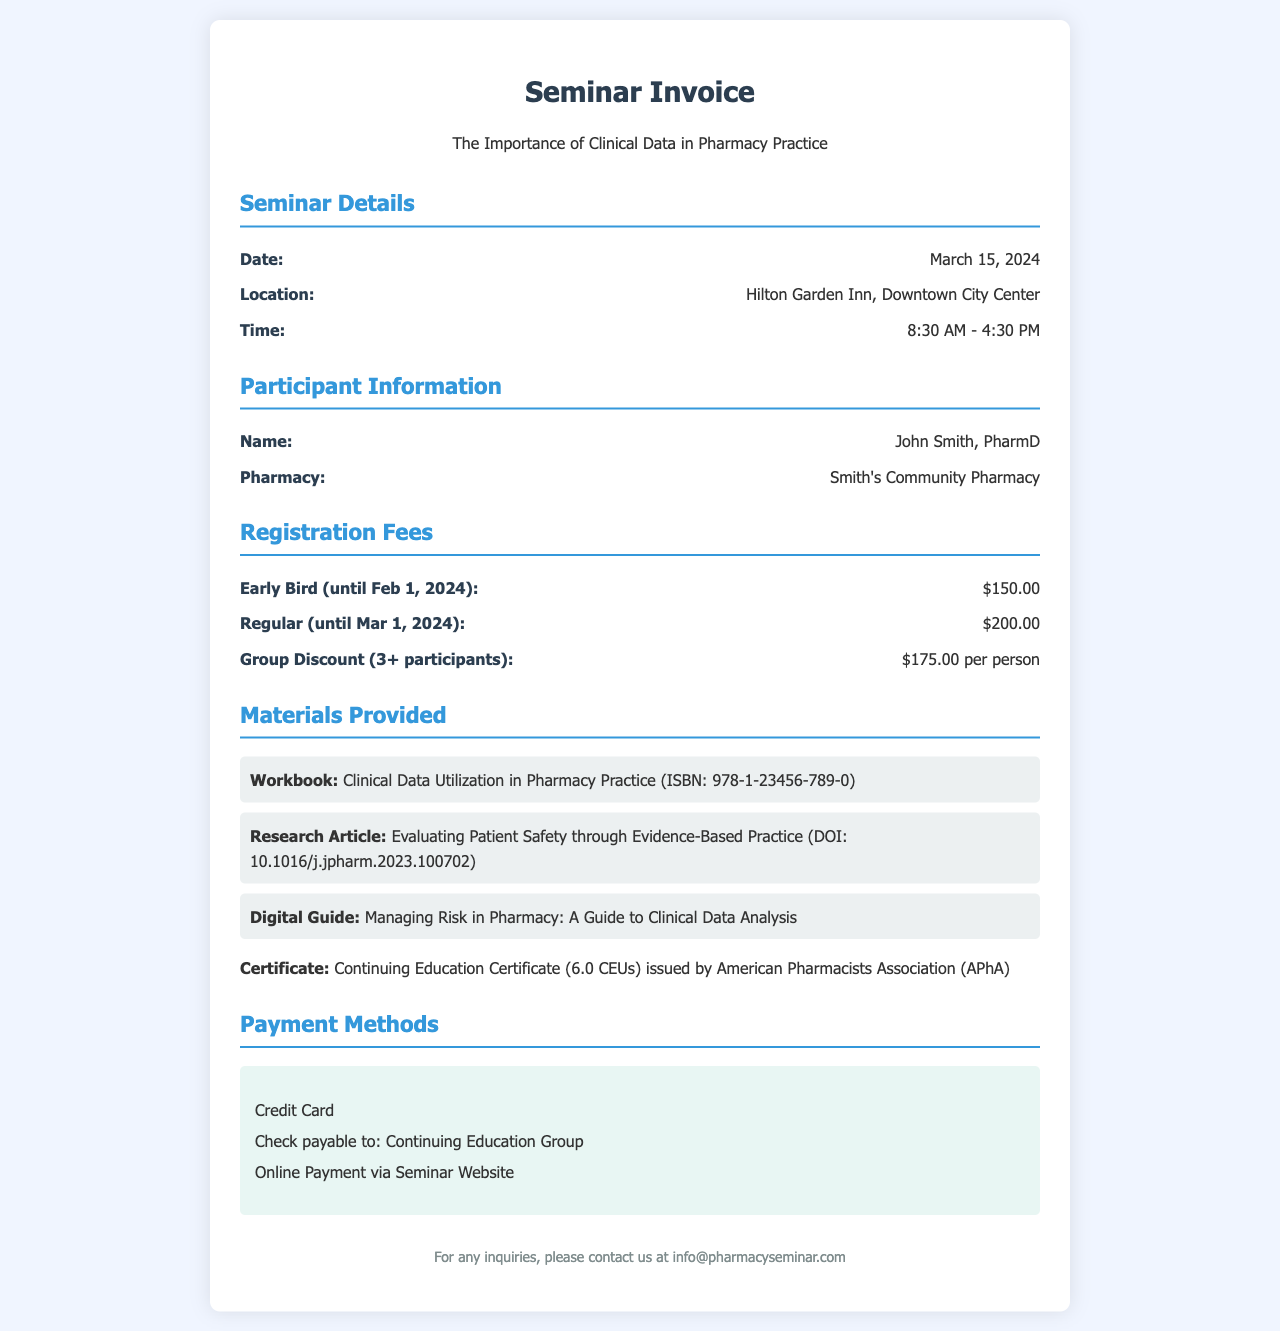What is the seminar date? The seminar date is explicitly mentioned in the document as March 15, 2024.
Answer: March 15, 2024 What is the early bird registration fee? The early bird registration fee stated is $150.00 until February 1, 2024.
Answer: $150.00 Who is the participant listed on the invoice? The document lists John Smith, PharmD as the participant.
Answer: John Smith, PharmD Where is the seminar location? The location of the seminar is provided as Hilton Garden Inn, Downtown City Center.
Answer: Hilton Garden Inn, Downtown City Center What is the certificate type provided at the seminar? The document specifies that a Continuing Education Certificate (6.0 CEUs) is issued.
Answer: Continuing Education Certificate (6.0 CEUs) How many CEUs are awarded for attending the seminar? The document indicates that attending the seminar awards 6.0 CEUs.
Answer: 6.0 CEUs What is the group discount price per person? The group discount for 3 or more participants is listed as $175.00 per person.
Answer: $175.00 per person What method of payment is mentioned for the seminar? Various payment methods are listed; one example is Credit Card.
Answer: Credit Card What is the title of the seminar? The invoice states the seminar title as "The Importance of Clinical Data in Pharmacy Practice."
Answer: The Importance of Clinical Data in Pharmacy Practice 